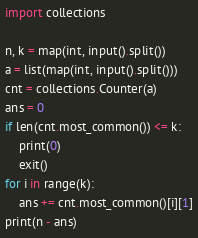<code> <loc_0><loc_0><loc_500><loc_500><_Python_>import collections

n, k = map(int, input().split())
a = list(map(int, input().split()))
cnt = collections.Counter(a)
ans = 0
if len(cnt.most_common()) <= k:
    print(0)
    exit()
for i in range(k):
    ans += cnt.most_common()[i][1]
print(n - ans)</code> 